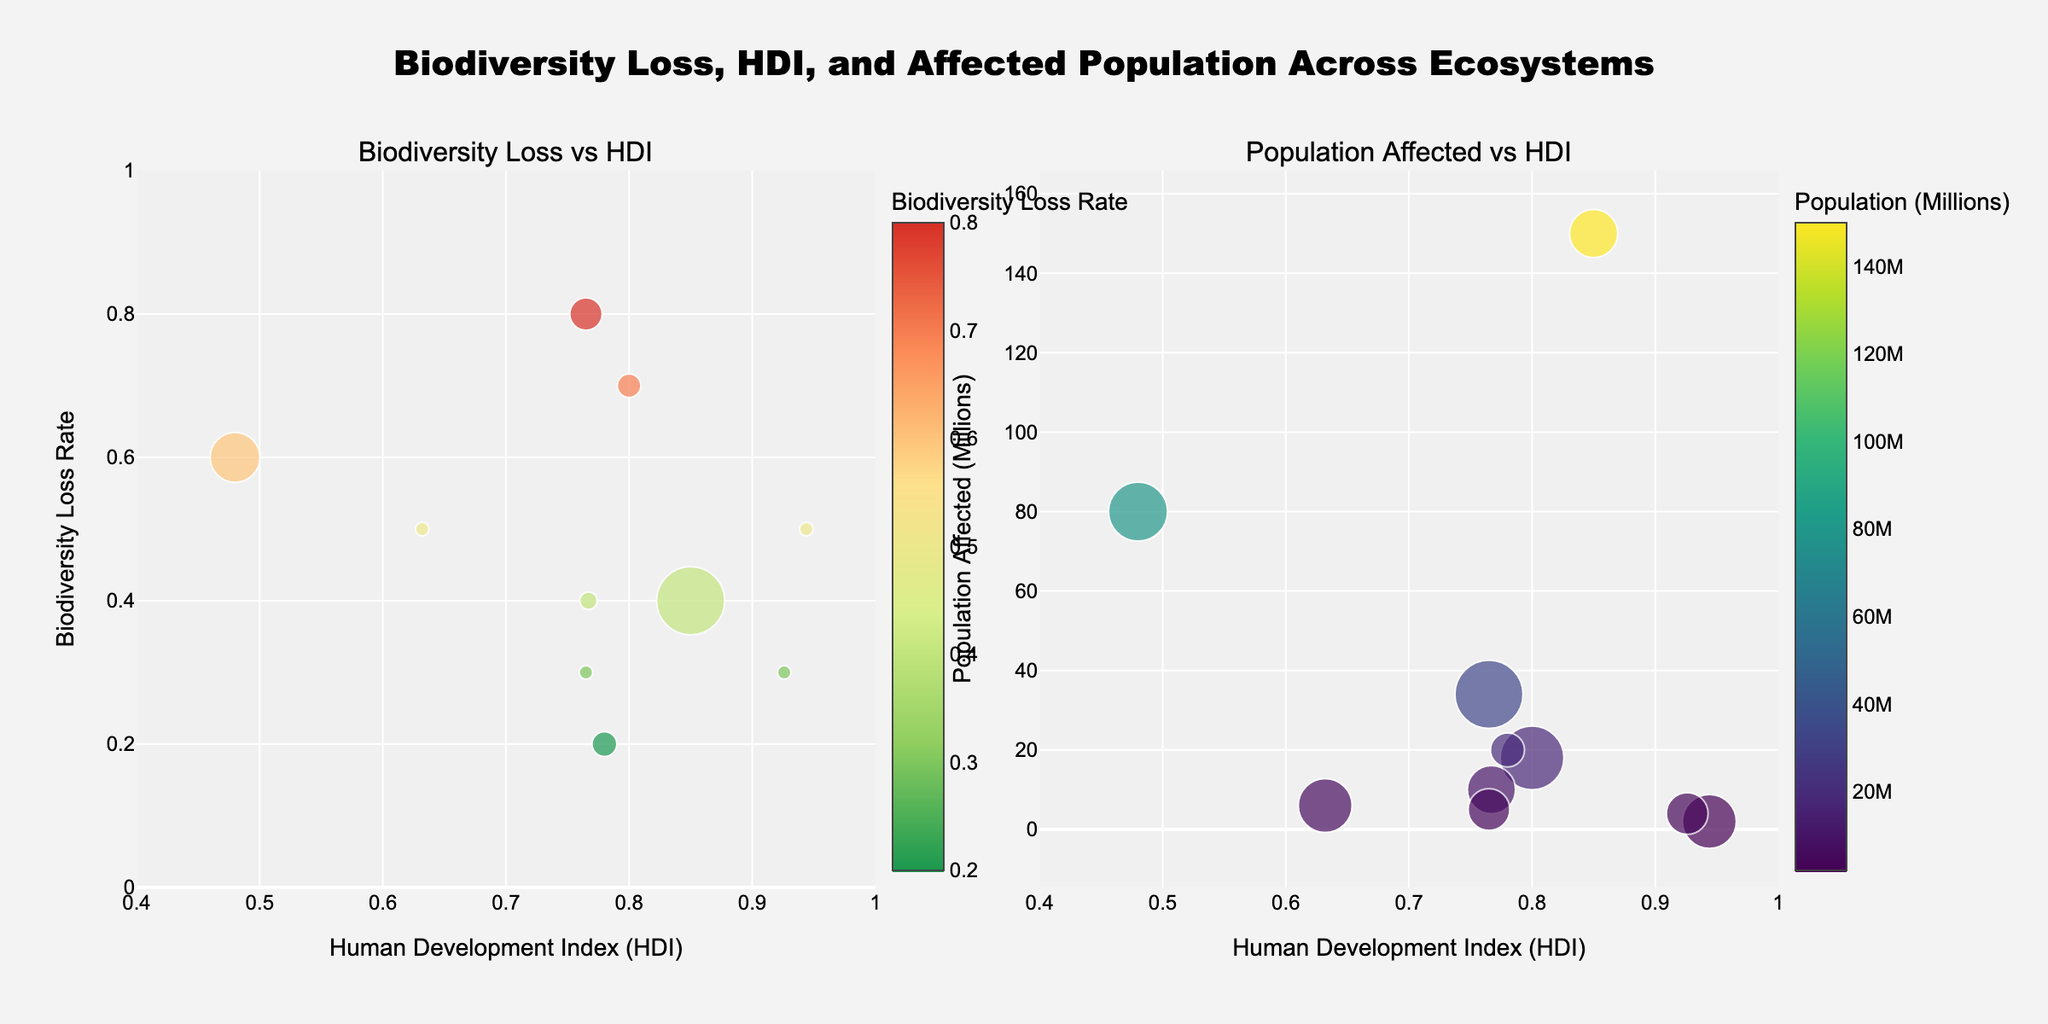Which ecosystem has the highest Biodiversity Loss Rate? Look at the left subplot and identify the highest point on the y-axis labeled "Biodiversity Loss Rate". The Amazon Rainforest has the highest rate with a value of 0.8.
Answer: Amazon Rainforest What is the Human Development Index (HDI) of the Great Barrier Reef? Locate the Great Barrier Reef on either subplot and check the corresponding value on the x-axis labeled "Human Development Index (HDI)". The HDI is 0.944.
Answer: 0.944 Which ecosystem affects the largest human population? Check the right subplot and find the largest bubble, as size represents the population affected in millions. The Mediterranean Basin has the largest bubble, indicating it affects 150 million people.
Answer: Mediterranean Basin Which two ecosystems have similar HDI but different Biodiversity Loss Rates? Look for ecosystems with close HDI values on the x-axis of the left subplot. Compare their y-axis values. Mesoamerican Reef (0.767) and Pantanal Wetlands (0.765) have similar HDIs but Biodiversity Loss Rates of 0.4 and 0.3, respectively.
Answer: Mesoamerican Reef and Pantanal Wetlands What is the relationship between Population Affected and HDI for the Arctic Tundra? Find the Arctic Tundra on the right subplot and observe its position on the x and y axes to determine its HDI and population affected. The Arctic Tundra has an HDI of 0.926 and affects about 4 million people.
Answer: HDI: 0.926, Population Affected: 4 million How does the Biodiversity Loss Rate of Sundarbans Mangroves compare to that of the Great Barrier Reef? Find both ecosystems on the left subplot and compare their positions on the y-axis. The Sundarbans Mangroves have a Biodiversity Loss Rate of 0.5, which is the same as the Great Barrier Reef.
Answer: Equal Which ecosystem in South America has a higher Biodiversity Loss Rate and a higher HDI? Focus on ecosystems in South America on the left subplot. Compare the Amazon Rainforest and Pantanal Wetlands for both HDI and Biodiversity Loss Rate. The Amazon Rainforest has higher values for both (0.8 vs. 0.3 and HDI of 0.765 vs. 0.765)
Answer: Amazon Rainforest What is the Biodiversity Loss Rate and Population Affected for the Congo Basin? Locate the Congo Basin on both subplots to find the relevant values. The Congo Basin has a Biodiversity Loss Rate of 0.6 and affects a population of 80 million.
Answer: Biodiversity Loss Rate: 0.6, Population Affected: 80 million Which region, South Asia or Southeast Asia, has a higher Biodiversity Loss Rate? Compare the Biodiversity Loss Rates of the ecosystems from the two regions on the left subplot. The Borneo Rainforest in Southeast Asia has a rate of 0.7, higher than the Sundarbans Mangroves in South Asia with 0.5.
Answer: Southeast Asia (Borneo Rainforest) What can be inferred about the relationship between HDI and Population Affected from the second subplot? Examine the distribution of bubbles on the right subplot to see if higher HDI correlates with larger or smaller populations affected. Populations affected do not consistently correlate with HDI – regions with high HDI like the Mediterranean Basin still have large affected populations, contrary to initial assumptions.
Answer: No consistent correlation 